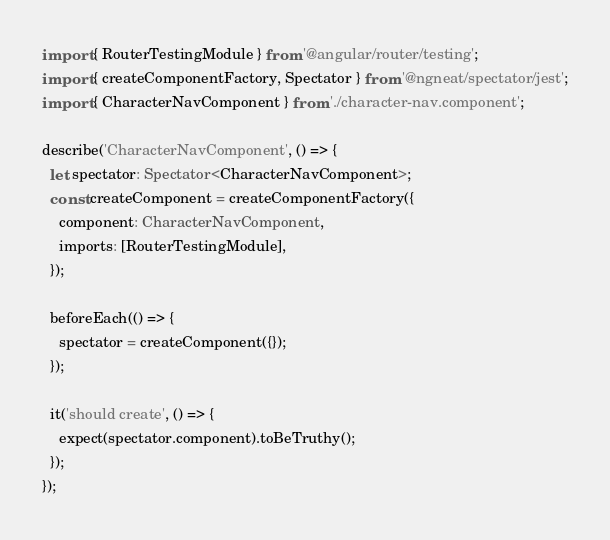Convert code to text. <code><loc_0><loc_0><loc_500><loc_500><_TypeScript_>import { RouterTestingModule } from '@angular/router/testing';
import { createComponentFactory, Spectator } from '@ngneat/spectator/jest';
import { CharacterNavComponent } from './character-nav.component';

describe('CharacterNavComponent', () => {
  let spectator: Spectator<CharacterNavComponent>;
  const createComponent = createComponentFactory({
    component: CharacterNavComponent,
    imports: [RouterTestingModule],
  });

  beforeEach(() => {
    spectator = createComponent({});
  });

  it('should create', () => {
    expect(spectator.component).toBeTruthy();
  });
});
</code> 